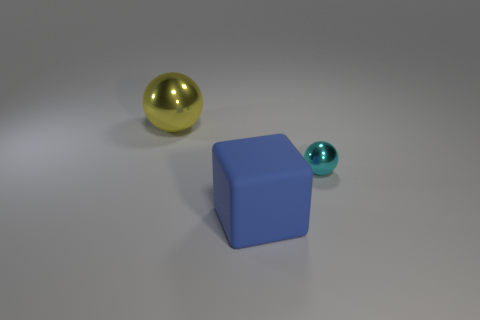Add 2 matte cubes. How many objects exist? 5 Subtract all cubes. How many objects are left? 2 Add 2 big yellow metallic spheres. How many big yellow metallic spheres are left? 3 Add 3 cyan spheres. How many cyan spheres exist? 4 Subtract 1 yellow balls. How many objects are left? 2 Subtract all large yellow matte blocks. Subtract all blue matte objects. How many objects are left? 2 